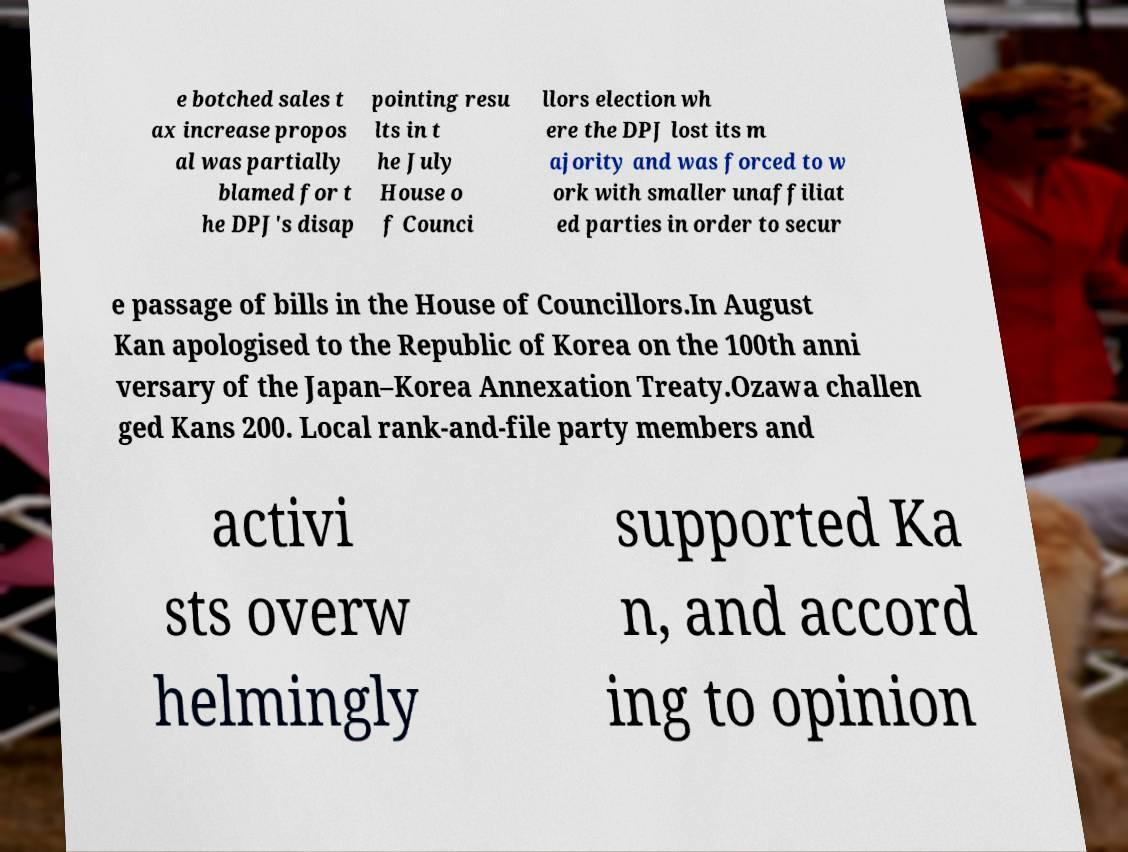Please read and relay the text visible in this image. What does it say? e botched sales t ax increase propos al was partially blamed for t he DPJ's disap pointing resu lts in t he July House o f Counci llors election wh ere the DPJ lost its m ajority and was forced to w ork with smaller unaffiliat ed parties in order to secur e passage of bills in the House of Councillors.In August Kan apologised to the Republic of Korea on the 100th anni versary of the Japan–Korea Annexation Treaty.Ozawa challen ged Kans 200. Local rank-and-file party members and activi sts overw helmingly supported Ka n, and accord ing to opinion 